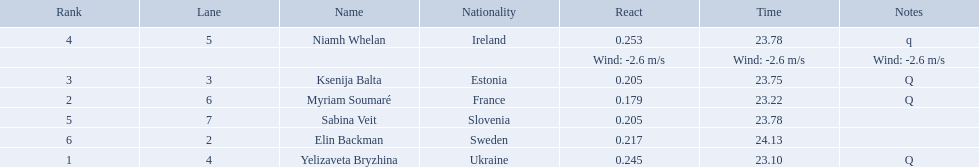Which athlete is from sweden? Elin Backman. What was their time to finish the race? 24.13. 